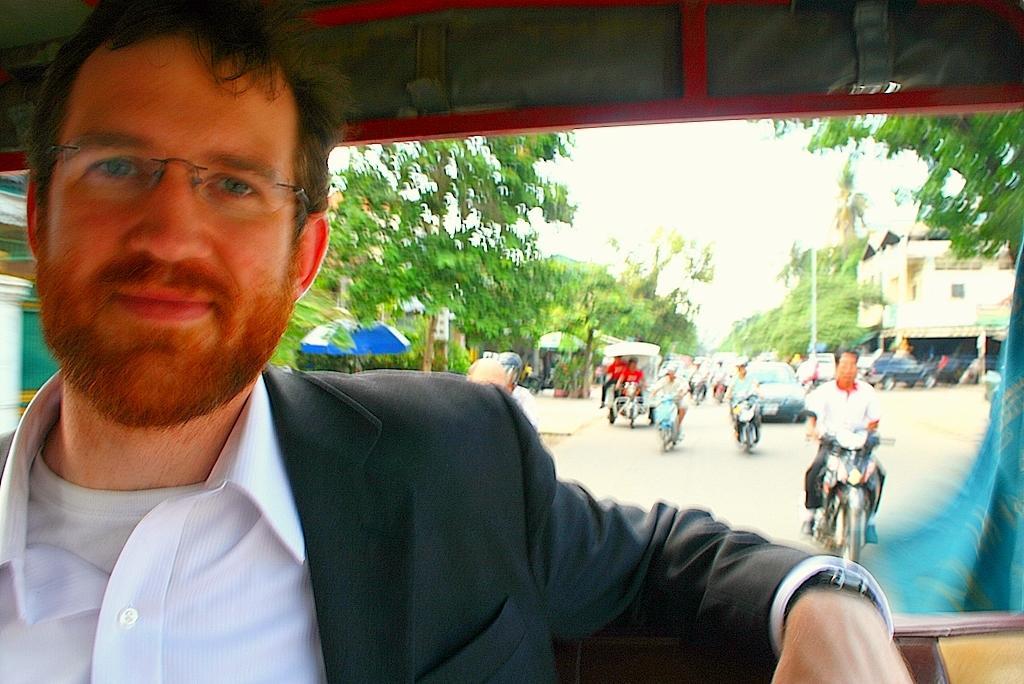Could you give a brief overview of what you see in this image? In this image I can see a person wearing the white and black color dress and sitting inside the vehicle. In the background I can see few people are riding the motor bikes and the vehicles on the road. These people are wearing the different color dresses. To the side of the road I can see the umbrellas and many trees. To the right I can see the building. In the background I can see the sky. 